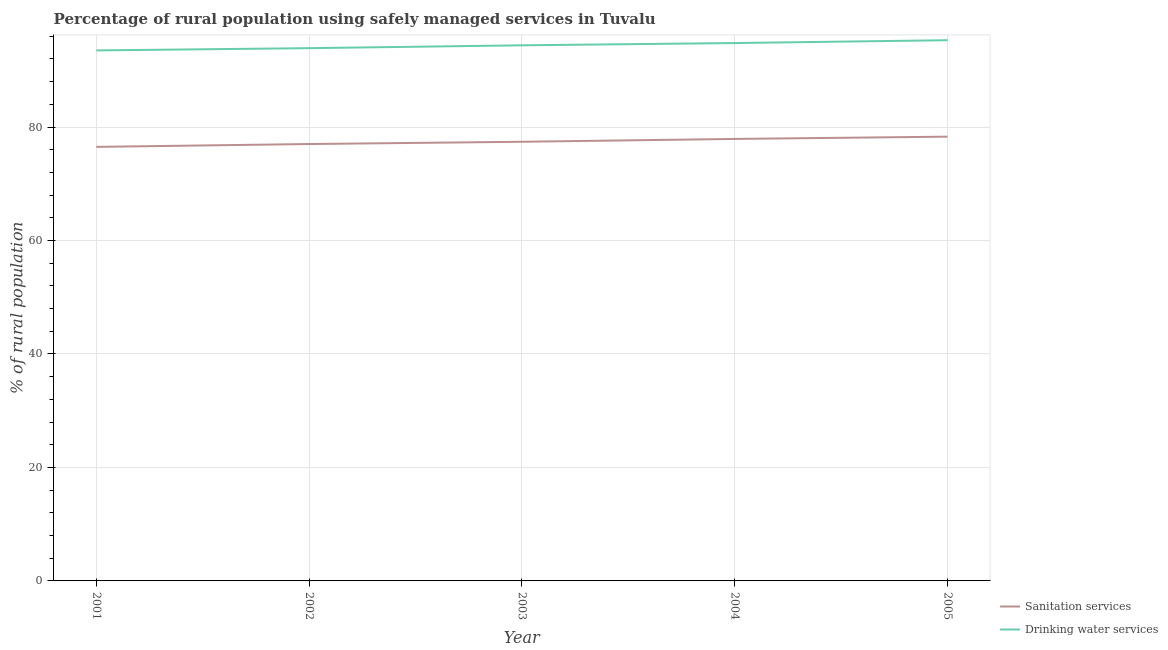Is the number of lines equal to the number of legend labels?
Your answer should be compact. Yes. What is the percentage of rural population who used drinking water services in 2002?
Give a very brief answer. 93.9. Across all years, what is the maximum percentage of rural population who used drinking water services?
Your answer should be compact. 95.3. Across all years, what is the minimum percentage of rural population who used sanitation services?
Offer a very short reply. 76.5. What is the total percentage of rural population who used sanitation services in the graph?
Offer a very short reply. 387.1. What is the difference between the percentage of rural population who used sanitation services in 2001 and that in 2005?
Provide a succinct answer. -1.8. What is the average percentage of rural population who used drinking water services per year?
Your answer should be compact. 94.38. In the year 2004, what is the difference between the percentage of rural population who used drinking water services and percentage of rural population who used sanitation services?
Offer a terse response. 16.9. In how many years, is the percentage of rural population who used drinking water services greater than 48 %?
Offer a terse response. 5. What is the ratio of the percentage of rural population who used sanitation services in 2002 to that in 2004?
Offer a very short reply. 0.99. What is the difference between the highest and the lowest percentage of rural population who used drinking water services?
Offer a very short reply. 1.8. In how many years, is the percentage of rural population who used sanitation services greater than the average percentage of rural population who used sanitation services taken over all years?
Keep it short and to the point. 2. Is the percentage of rural population who used drinking water services strictly less than the percentage of rural population who used sanitation services over the years?
Your answer should be compact. No. How many lines are there?
Keep it short and to the point. 2. How many years are there in the graph?
Your answer should be very brief. 5. Are the values on the major ticks of Y-axis written in scientific E-notation?
Your answer should be compact. No. Does the graph contain grids?
Your answer should be very brief. Yes. How many legend labels are there?
Your answer should be very brief. 2. What is the title of the graph?
Provide a succinct answer. Percentage of rural population using safely managed services in Tuvalu. Does "Exports of goods" appear as one of the legend labels in the graph?
Your answer should be very brief. No. What is the label or title of the X-axis?
Offer a very short reply. Year. What is the label or title of the Y-axis?
Offer a very short reply. % of rural population. What is the % of rural population in Sanitation services in 2001?
Make the answer very short. 76.5. What is the % of rural population in Drinking water services in 2001?
Provide a succinct answer. 93.5. What is the % of rural population of Drinking water services in 2002?
Your response must be concise. 93.9. What is the % of rural population in Sanitation services in 2003?
Offer a terse response. 77.4. What is the % of rural population in Drinking water services in 2003?
Provide a short and direct response. 94.4. What is the % of rural population in Sanitation services in 2004?
Provide a succinct answer. 77.9. What is the % of rural population in Drinking water services in 2004?
Your answer should be compact. 94.8. What is the % of rural population of Sanitation services in 2005?
Your answer should be very brief. 78.3. What is the % of rural population in Drinking water services in 2005?
Provide a short and direct response. 95.3. Across all years, what is the maximum % of rural population in Sanitation services?
Offer a terse response. 78.3. Across all years, what is the maximum % of rural population of Drinking water services?
Provide a succinct answer. 95.3. Across all years, what is the minimum % of rural population in Sanitation services?
Your answer should be compact. 76.5. Across all years, what is the minimum % of rural population of Drinking water services?
Your answer should be very brief. 93.5. What is the total % of rural population of Sanitation services in the graph?
Provide a succinct answer. 387.1. What is the total % of rural population in Drinking water services in the graph?
Keep it short and to the point. 471.9. What is the difference between the % of rural population in Drinking water services in 2001 and that in 2003?
Make the answer very short. -0.9. What is the difference between the % of rural population in Sanitation services in 2001 and that in 2004?
Your answer should be compact. -1.4. What is the difference between the % of rural population of Drinking water services in 2001 and that in 2004?
Provide a succinct answer. -1.3. What is the difference between the % of rural population of Sanitation services in 2001 and that in 2005?
Your answer should be compact. -1.8. What is the difference between the % of rural population in Drinking water services in 2001 and that in 2005?
Ensure brevity in your answer.  -1.8. What is the difference between the % of rural population of Sanitation services in 2002 and that in 2003?
Your response must be concise. -0.4. What is the difference between the % of rural population of Sanitation services in 2002 and that in 2005?
Ensure brevity in your answer.  -1.3. What is the difference between the % of rural population of Drinking water services in 2002 and that in 2005?
Provide a succinct answer. -1.4. What is the difference between the % of rural population in Sanitation services in 2003 and that in 2004?
Keep it short and to the point. -0.5. What is the difference between the % of rural population of Sanitation services in 2001 and the % of rural population of Drinking water services in 2002?
Make the answer very short. -17.4. What is the difference between the % of rural population in Sanitation services in 2001 and the % of rural population in Drinking water services in 2003?
Keep it short and to the point. -17.9. What is the difference between the % of rural population of Sanitation services in 2001 and the % of rural population of Drinking water services in 2004?
Make the answer very short. -18.3. What is the difference between the % of rural population of Sanitation services in 2001 and the % of rural population of Drinking water services in 2005?
Give a very brief answer. -18.8. What is the difference between the % of rural population of Sanitation services in 2002 and the % of rural population of Drinking water services in 2003?
Give a very brief answer. -17.4. What is the difference between the % of rural population in Sanitation services in 2002 and the % of rural population in Drinking water services in 2004?
Your response must be concise. -17.8. What is the difference between the % of rural population in Sanitation services in 2002 and the % of rural population in Drinking water services in 2005?
Provide a succinct answer. -18.3. What is the difference between the % of rural population in Sanitation services in 2003 and the % of rural population in Drinking water services in 2004?
Keep it short and to the point. -17.4. What is the difference between the % of rural population in Sanitation services in 2003 and the % of rural population in Drinking water services in 2005?
Offer a terse response. -17.9. What is the difference between the % of rural population in Sanitation services in 2004 and the % of rural population in Drinking water services in 2005?
Give a very brief answer. -17.4. What is the average % of rural population in Sanitation services per year?
Provide a succinct answer. 77.42. What is the average % of rural population in Drinking water services per year?
Provide a succinct answer. 94.38. In the year 2002, what is the difference between the % of rural population in Sanitation services and % of rural population in Drinking water services?
Your answer should be compact. -16.9. In the year 2003, what is the difference between the % of rural population of Sanitation services and % of rural population of Drinking water services?
Your response must be concise. -17. In the year 2004, what is the difference between the % of rural population of Sanitation services and % of rural population of Drinking water services?
Keep it short and to the point. -16.9. What is the ratio of the % of rural population of Sanitation services in 2001 to that in 2003?
Provide a short and direct response. 0.99. What is the ratio of the % of rural population of Drinking water services in 2001 to that in 2004?
Offer a very short reply. 0.99. What is the ratio of the % of rural population in Sanitation services in 2001 to that in 2005?
Your response must be concise. 0.98. What is the ratio of the % of rural population in Drinking water services in 2001 to that in 2005?
Offer a very short reply. 0.98. What is the ratio of the % of rural population in Sanitation services in 2002 to that in 2003?
Your response must be concise. 0.99. What is the ratio of the % of rural population in Sanitation services in 2002 to that in 2004?
Your answer should be very brief. 0.99. What is the ratio of the % of rural population of Drinking water services in 2002 to that in 2004?
Provide a short and direct response. 0.99. What is the ratio of the % of rural population in Sanitation services in 2002 to that in 2005?
Provide a succinct answer. 0.98. What is the ratio of the % of rural population in Drinking water services in 2002 to that in 2005?
Your response must be concise. 0.99. What is the ratio of the % of rural population of Sanitation services in 2003 to that in 2005?
Your response must be concise. 0.99. What is the ratio of the % of rural population in Drinking water services in 2003 to that in 2005?
Offer a terse response. 0.99. What is the ratio of the % of rural population in Sanitation services in 2004 to that in 2005?
Make the answer very short. 0.99. What is the ratio of the % of rural population in Drinking water services in 2004 to that in 2005?
Your response must be concise. 0.99. What is the difference between the highest and the lowest % of rural population of Sanitation services?
Offer a very short reply. 1.8. 